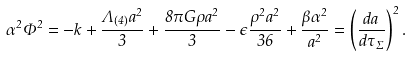<formula> <loc_0><loc_0><loc_500><loc_500>\alpha ^ { 2 } \Phi ^ { 2 } = - k + \frac { \Lambda _ { ( 4 ) } a ^ { 2 } } { 3 } + \frac { 8 \pi G \rho a ^ { 2 } } { 3 } - \epsilon \frac { \rho ^ { 2 } a ^ { 2 } } { 3 6 } + \frac { \beta \alpha ^ { 2 } } { a ^ { 2 } } = \left ( \frac { d a } { d \tau _ { \Sigma } } \right ) ^ { 2 } .</formula> 